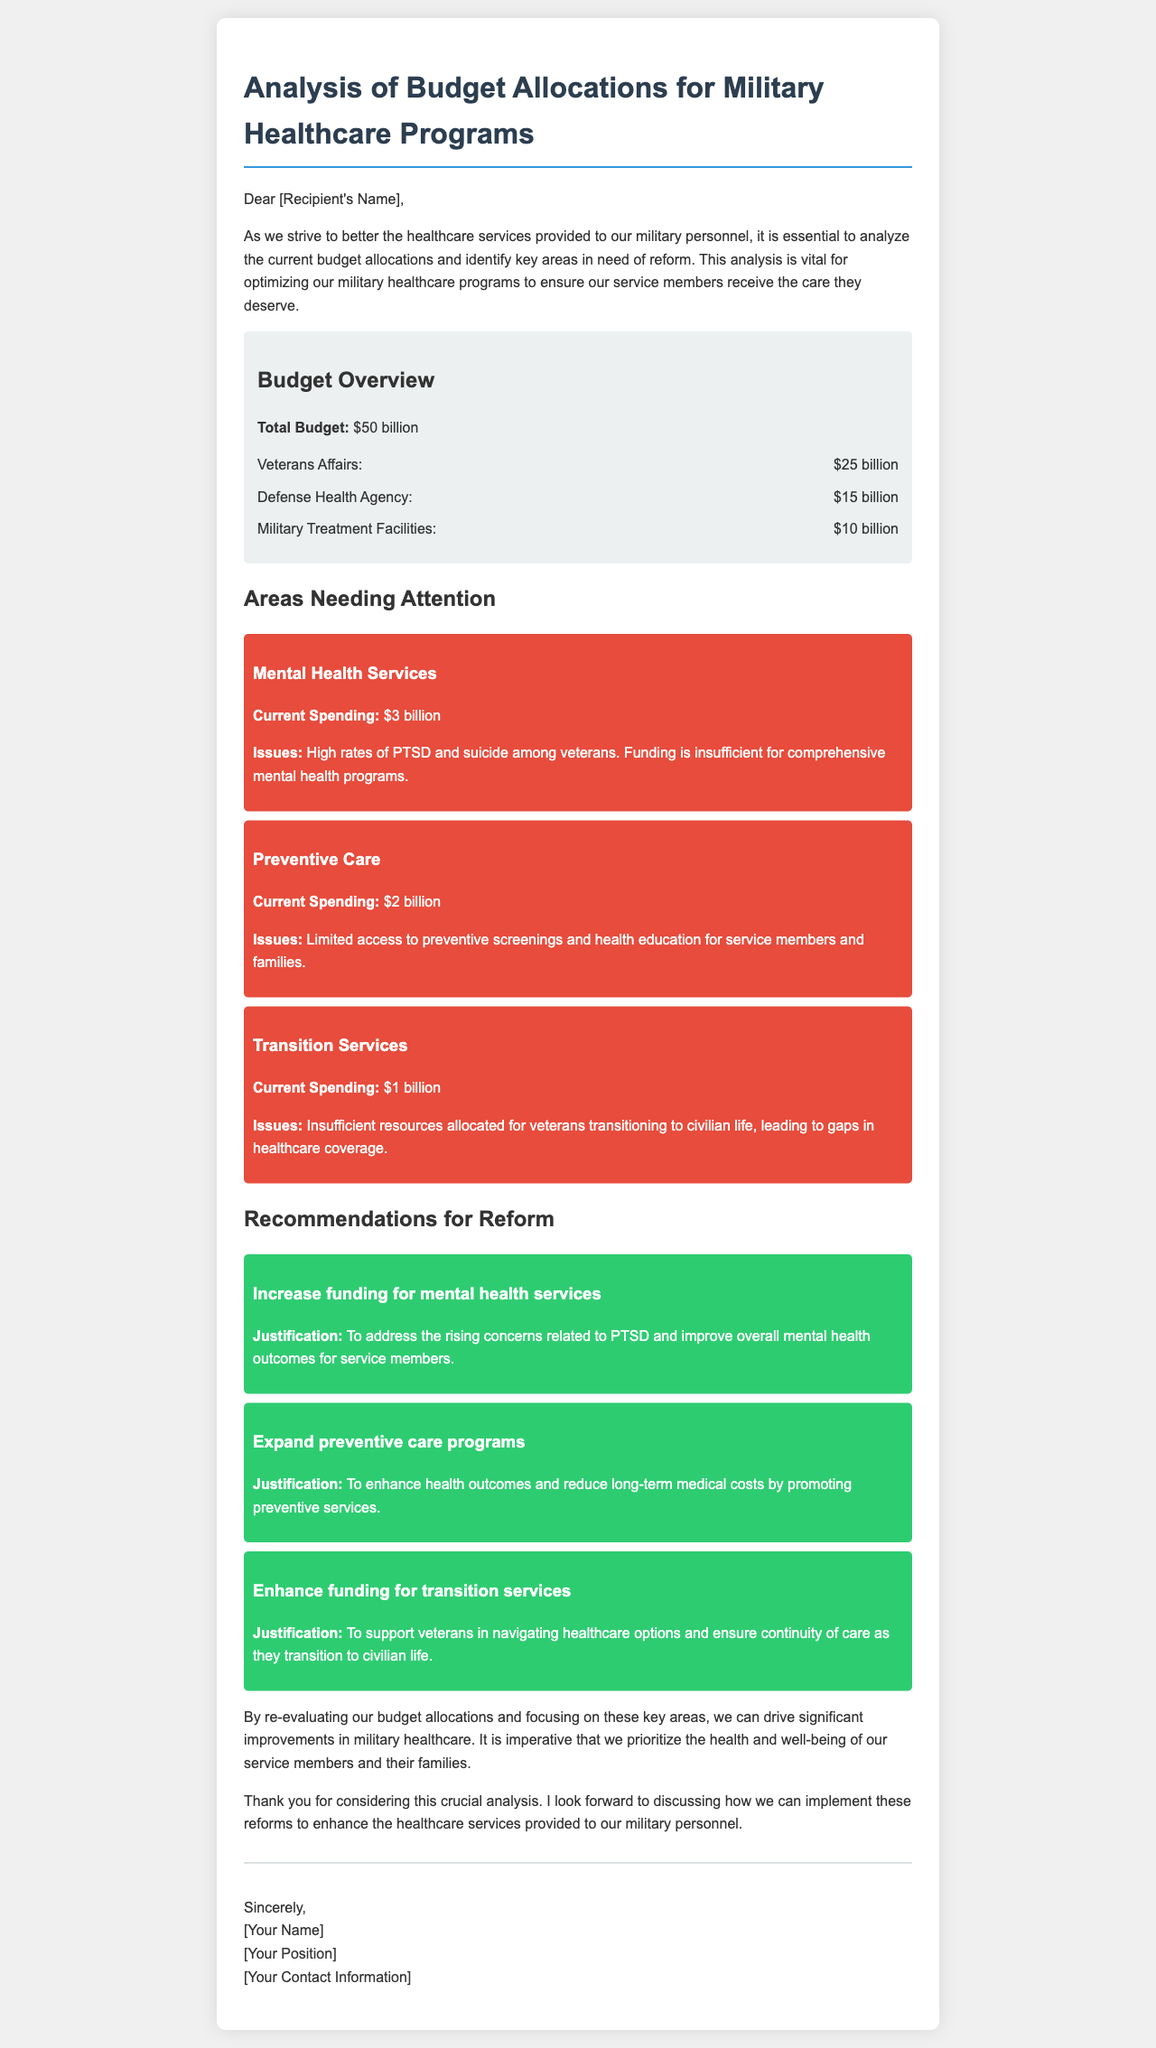What is the total budget for military healthcare programs? The total budget for military healthcare programs is stated in the budget overview section of the document.
Answer: $50 billion How much is allocated to Veterans Affairs? The document specifies the funding distribution in the budget overview.
Answer: $25 billion What issue is associated with mental health services? The document lists specific issues related to various services, particularly mental health.
Answer: High rates of PTSD and suicide among veterans What is the current spending on preventive care? The current spending for preventive care is detailed in the areas needing attention section.
Answer: $2 billion What recommendation is made for mental health services? The document provides recommendations for reform regarding mental health services.
Answer: Increase funding for mental health services How much is spent on transition services? The document explicitly states the current budget allocations for transition services.
Answer: $1 billion What is the justification for enhancing funding for transition services? The justification is provided for each recommendation, particularly regarding transition services.
Answer: To support veterans in navigating healthcare options What does the budget overview consist of? The document outlines the components included in the budget overview section.
Answer: Total Budget, Veterans Affairs, Defense Health Agency, Military Treatment Facilities 